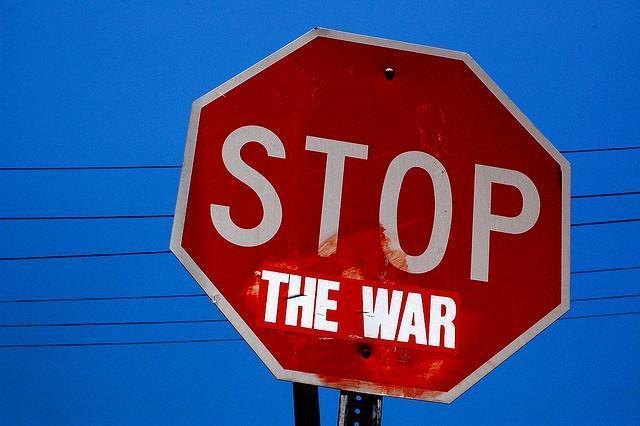How many electrical lines are behind the sign?
Give a very brief answer. 6. 